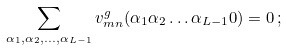Convert formula to latex. <formula><loc_0><loc_0><loc_500><loc_500>\sum _ { \alpha _ { 1 } , \alpha _ { 2 } , \dots , \alpha _ { L - 1 } } { v } _ { m n } ^ { g } ( \alpha _ { 1 } \alpha _ { 2 } \dots \alpha _ { L - 1 } 0 ) = 0 \, ;</formula> 